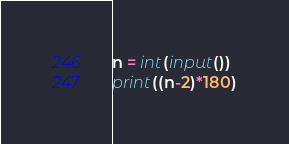Convert code to text. <code><loc_0><loc_0><loc_500><loc_500><_Python_>n = int(input())
print((n-2)*180)</code> 